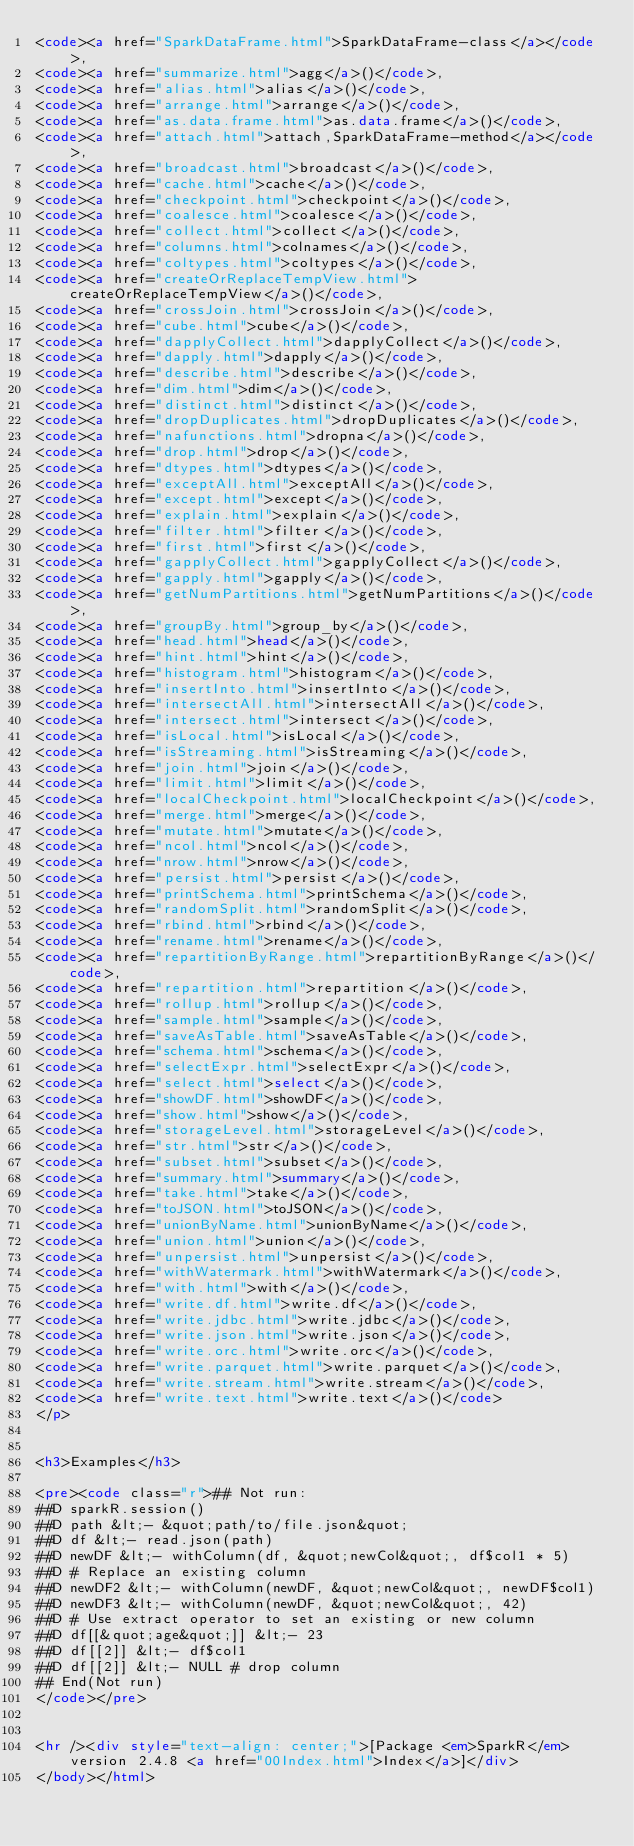Convert code to text. <code><loc_0><loc_0><loc_500><loc_500><_HTML_><code><a href="SparkDataFrame.html">SparkDataFrame-class</a></code>,
<code><a href="summarize.html">agg</a>()</code>,
<code><a href="alias.html">alias</a>()</code>,
<code><a href="arrange.html">arrange</a>()</code>,
<code><a href="as.data.frame.html">as.data.frame</a>()</code>,
<code><a href="attach.html">attach,SparkDataFrame-method</a></code>,
<code><a href="broadcast.html">broadcast</a>()</code>,
<code><a href="cache.html">cache</a>()</code>,
<code><a href="checkpoint.html">checkpoint</a>()</code>,
<code><a href="coalesce.html">coalesce</a>()</code>,
<code><a href="collect.html">collect</a>()</code>,
<code><a href="columns.html">colnames</a>()</code>,
<code><a href="coltypes.html">coltypes</a>()</code>,
<code><a href="createOrReplaceTempView.html">createOrReplaceTempView</a>()</code>,
<code><a href="crossJoin.html">crossJoin</a>()</code>,
<code><a href="cube.html">cube</a>()</code>,
<code><a href="dapplyCollect.html">dapplyCollect</a>()</code>,
<code><a href="dapply.html">dapply</a>()</code>,
<code><a href="describe.html">describe</a>()</code>,
<code><a href="dim.html">dim</a>()</code>,
<code><a href="distinct.html">distinct</a>()</code>,
<code><a href="dropDuplicates.html">dropDuplicates</a>()</code>,
<code><a href="nafunctions.html">dropna</a>()</code>,
<code><a href="drop.html">drop</a>()</code>,
<code><a href="dtypes.html">dtypes</a>()</code>,
<code><a href="exceptAll.html">exceptAll</a>()</code>,
<code><a href="except.html">except</a>()</code>,
<code><a href="explain.html">explain</a>()</code>,
<code><a href="filter.html">filter</a>()</code>,
<code><a href="first.html">first</a>()</code>,
<code><a href="gapplyCollect.html">gapplyCollect</a>()</code>,
<code><a href="gapply.html">gapply</a>()</code>,
<code><a href="getNumPartitions.html">getNumPartitions</a>()</code>,
<code><a href="groupBy.html">group_by</a>()</code>,
<code><a href="head.html">head</a>()</code>,
<code><a href="hint.html">hint</a>()</code>,
<code><a href="histogram.html">histogram</a>()</code>,
<code><a href="insertInto.html">insertInto</a>()</code>,
<code><a href="intersectAll.html">intersectAll</a>()</code>,
<code><a href="intersect.html">intersect</a>()</code>,
<code><a href="isLocal.html">isLocal</a>()</code>,
<code><a href="isStreaming.html">isStreaming</a>()</code>,
<code><a href="join.html">join</a>()</code>,
<code><a href="limit.html">limit</a>()</code>,
<code><a href="localCheckpoint.html">localCheckpoint</a>()</code>,
<code><a href="merge.html">merge</a>()</code>,
<code><a href="mutate.html">mutate</a>()</code>,
<code><a href="ncol.html">ncol</a>()</code>,
<code><a href="nrow.html">nrow</a>()</code>,
<code><a href="persist.html">persist</a>()</code>,
<code><a href="printSchema.html">printSchema</a>()</code>,
<code><a href="randomSplit.html">randomSplit</a>()</code>,
<code><a href="rbind.html">rbind</a>()</code>,
<code><a href="rename.html">rename</a>()</code>,
<code><a href="repartitionByRange.html">repartitionByRange</a>()</code>,
<code><a href="repartition.html">repartition</a>()</code>,
<code><a href="rollup.html">rollup</a>()</code>,
<code><a href="sample.html">sample</a>()</code>,
<code><a href="saveAsTable.html">saveAsTable</a>()</code>,
<code><a href="schema.html">schema</a>()</code>,
<code><a href="selectExpr.html">selectExpr</a>()</code>,
<code><a href="select.html">select</a>()</code>,
<code><a href="showDF.html">showDF</a>()</code>,
<code><a href="show.html">show</a>()</code>,
<code><a href="storageLevel.html">storageLevel</a>()</code>,
<code><a href="str.html">str</a>()</code>,
<code><a href="subset.html">subset</a>()</code>,
<code><a href="summary.html">summary</a>()</code>,
<code><a href="take.html">take</a>()</code>,
<code><a href="toJSON.html">toJSON</a>()</code>,
<code><a href="unionByName.html">unionByName</a>()</code>,
<code><a href="union.html">union</a>()</code>,
<code><a href="unpersist.html">unpersist</a>()</code>,
<code><a href="withWatermark.html">withWatermark</a>()</code>,
<code><a href="with.html">with</a>()</code>,
<code><a href="write.df.html">write.df</a>()</code>,
<code><a href="write.jdbc.html">write.jdbc</a>()</code>,
<code><a href="write.json.html">write.json</a>()</code>,
<code><a href="write.orc.html">write.orc</a>()</code>,
<code><a href="write.parquet.html">write.parquet</a>()</code>,
<code><a href="write.stream.html">write.stream</a>()</code>,
<code><a href="write.text.html">write.text</a>()</code>
</p>


<h3>Examples</h3>

<pre><code class="r">## Not run: 
##D sparkR.session()
##D path &lt;- &quot;path/to/file.json&quot;
##D df &lt;- read.json(path)
##D newDF &lt;- withColumn(df, &quot;newCol&quot;, df$col1 * 5)
##D # Replace an existing column
##D newDF2 &lt;- withColumn(newDF, &quot;newCol&quot;, newDF$col1)
##D newDF3 &lt;- withColumn(newDF, &quot;newCol&quot;, 42)
##D # Use extract operator to set an existing or new column
##D df[[&quot;age&quot;]] &lt;- 23
##D df[[2]] &lt;- df$col1
##D df[[2]] &lt;- NULL # drop column
## End(Not run)
</code></pre>


<hr /><div style="text-align: center;">[Package <em>SparkR</em> version 2.4.8 <a href="00Index.html">Index</a>]</div>
</body></html>
</code> 